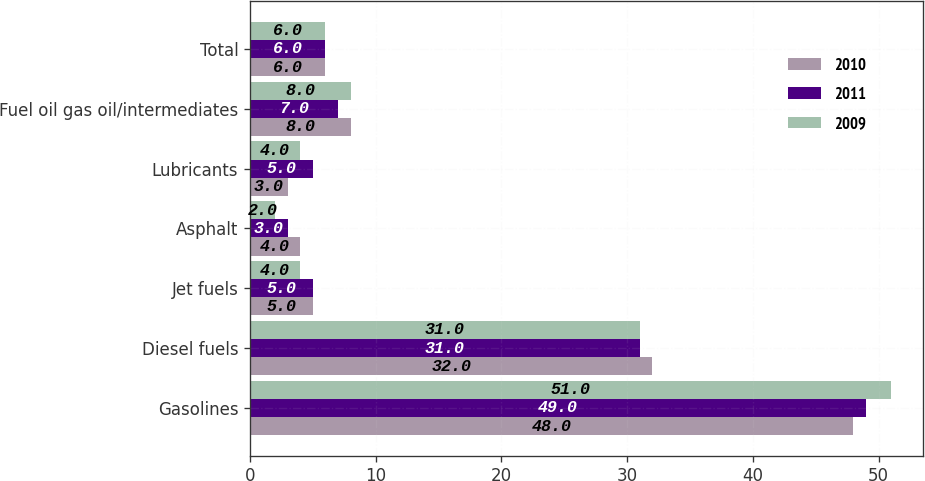<chart> <loc_0><loc_0><loc_500><loc_500><stacked_bar_chart><ecel><fcel>Gasolines<fcel>Diesel fuels<fcel>Jet fuels<fcel>Asphalt<fcel>Lubricants<fcel>Fuel oil gas oil/intermediates<fcel>Total<nl><fcel>2010<fcel>48<fcel>32<fcel>5<fcel>4<fcel>3<fcel>8<fcel>6<nl><fcel>2011<fcel>49<fcel>31<fcel>5<fcel>3<fcel>5<fcel>7<fcel>6<nl><fcel>2009<fcel>51<fcel>31<fcel>4<fcel>2<fcel>4<fcel>8<fcel>6<nl></chart> 